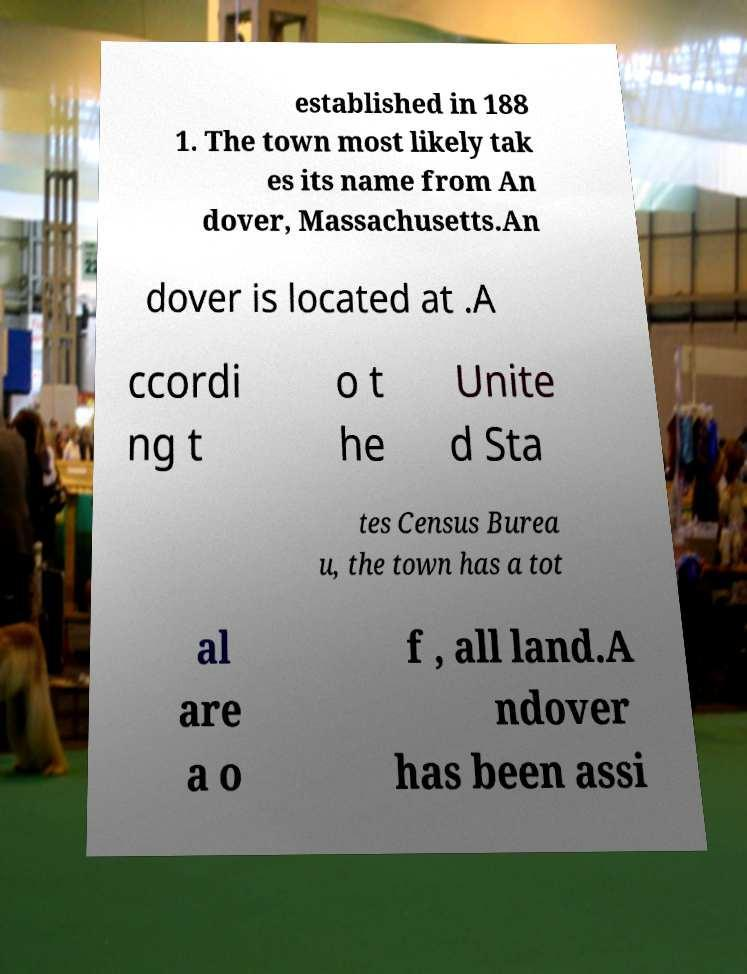Please identify and transcribe the text found in this image. established in 188 1. The town most likely tak es its name from An dover, Massachusetts.An dover is located at .A ccordi ng t o t he Unite d Sta tes Census Burea u, the town has a tot al are a o f , all land.A ndover has been assi 